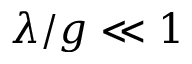<formula> <loc_0><loc_0><loc_500><loc_500>\lambda / g \ll 1</formula> 